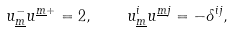Convert formula to latex. <formula><loc_0><loc_0><loc_500><loc_500>u _ { \underline { m } } ^ { - } u ^ { \underline { m } + } = 2 , \quad u _ { \underline { m } } ^ { i } u ^ { \underline { m } j } = - \delta ^ { i j } ,</formula> 